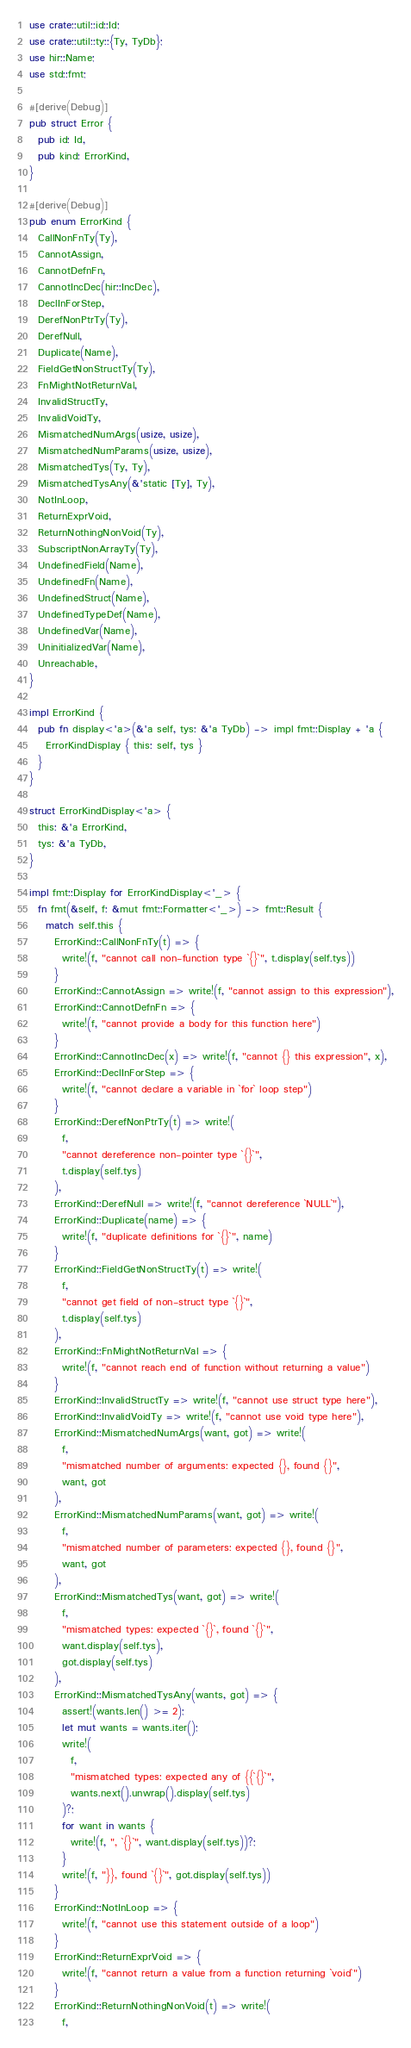<code> <loc_0><loc_0><loc_500><loc_500><_Rust_>use crate::util::id::Id;
use crate::util::ty::{Ty, TyDb};
use hir::Name;
use std::fmt;

#[derive(Debug)]
pub struct Error {
  pub id: Id,
  pub kind: ErrorKind,
}

#[derive(Debug)]
pub enum ErrorKind {
  CallNonFnTy(Ty),
  CannotAssign,
  CannotDefnFn,
  CannotIncDec(hir::IncDec),
  DeclInForStep,
  DerefNonPtrTy(Ty),
  DerefNull,
  Duplicate(Name),
  FieldGetNonStructTy(Ty),
  FnMightNotReturnVal,
  InvalidStructTy,
  InvalidVoidTy,
  MismatchedNumArgs(usize, usize),
  MismatchedNumParams(usize, usize),
  MismatchedTys(Ty, Ty),
  MismatchedTysAny(&'static [Ty], Ty),
  NotInLoop,
  ReturnExprVoid,
  ReturnNothingNonVoid(Ty),
  SubscriptNonArrayTy(Ty),
  UndefinedField(Name),
  UndefinedFn(Name),
  UndefinedStruct(Name),
  UndefinedTypeDef(Name),
  UndefinedVar(Name),
  UninitializedVar(Name),
  Unreachable,
}

impl ErrorKind {
  pub fn display<'a>(&'a self, tys: &'a TyDb) -> impl fmt::Display + 'a {
    ErrorKindDisplay { this: self, tys }
  }
}

struct ErrorKindDisplay<'a> {
  this: &'a ErrorKind,
  tys: &'a TyDb,
}

impl fmt::Display for ErrorKindDisplay<'_> {
  fn fmt(&self, f: &mut fmt::Formatter<'_>) -> fmt::Result {
    match self.this {
      ErrorKind::CallNonFnTy(t) => {
        write!(f, "cannot call non-function type `{}`", t.display(self.tys))
      }
      ErrorKind::CannotAssign => write!(f, "cannot assign to this expression"),
      ErrorKind::CannotDefnFn => {
        write!(f, "cannot provide a body for this function here")
      }
      ErrorKind::CannotIncDec(x) => write!(f, "cannot {} this expression", x),
      ErrorKind::DeclInForStep => {
        write!(f, "cannot declare a variable in `for` loop step")
      }
      ErrorKind::DerefNonPtrTy(t) => write!(
        f,
        "cannot dereference non-pointer type `{}`",
        t.display(self.tys)
      ),
      ErrorKind::DerefNull => write!(f, "cannot dereference `NULL`"),
      ErrorKind::Duplicate(name) => {
        write!(f, "duplicate definitions for `{}`", name)
      }
      ErrorKind::FieldGetNonStructTy(t) => write!(
        f,
        "cannot get field of non-struct type `{}`",
        t.display(self.tys)
      ),
      ErrorKind::FnMightNotReturnVal => {
        write!(f, "cannot reach end of function without returning a value")
      }
      ErrorKind::InvalidStructTy => write!(f, "cannot use struct type here"),
      ErrorKind::InvalidVoidTy => write!(f, "cannot use void type here"),
      ErrorKind::MismatchedNumArgs(want, got) => write!(
        f,
        "mismatched number of arguments: expected {}, found {}",
        want, got
      ),
      ErrorKind::MismatchedNumParams(want, got) => write!(
        f,
        "mismatched number of parameters: expected {}, found {}",
        want, got
      ),
      ErrorKind::MismatchedTys(want, got) => write!(
        f,
        "mismatched types: expected `{}`, found `{}`",
        want.display(self.tys),
        got.display(self.tys)
      ),
      ErrorKind::MismatchedTysAny(wants, got) => {
        assert!(wants.len() >= 2);
        let mut wants = wants.iter();
        write!(
          f,
          "mismatched types: expected any of {{`{}`",
          wants.next().unwrap().display(self.tys)
        )?;
        for want in wants {
          write!(f, ", `{}`", want.display(self.tys))?;
        }
        write!(f, "}}, found `{}`", got.display(self.tys))
      }
      ErrorKind::NotInLoop => {
        write!(f, "cannot use this statement outside of a loop")
      }
      ErrorKind::ReturnExprVoid => {
        write!(f, "cannot return a value from a function returning `void`")
      }
      ErrorKind::ReturnNothingNonVoid(t) => write!(
        f,</code> 